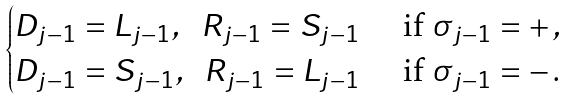<formula> <loc_0><loc_0><loc_500><loc_500>\begin{cases} D _ { j - 1 } = L _ { j - 1 } , \ \ R _ { j - 1 } = S _ { j - 1 } & \text { if } \sigma _ { j - 1 } = + \, , \\ D _ { j - 1 } = S _ { j - 1 } , \ \ R _ { j - 1 } = L _ { j - 1 } & \text { if } \sigma _ { j - 1 } = - \, . \end{cases}</formula> 